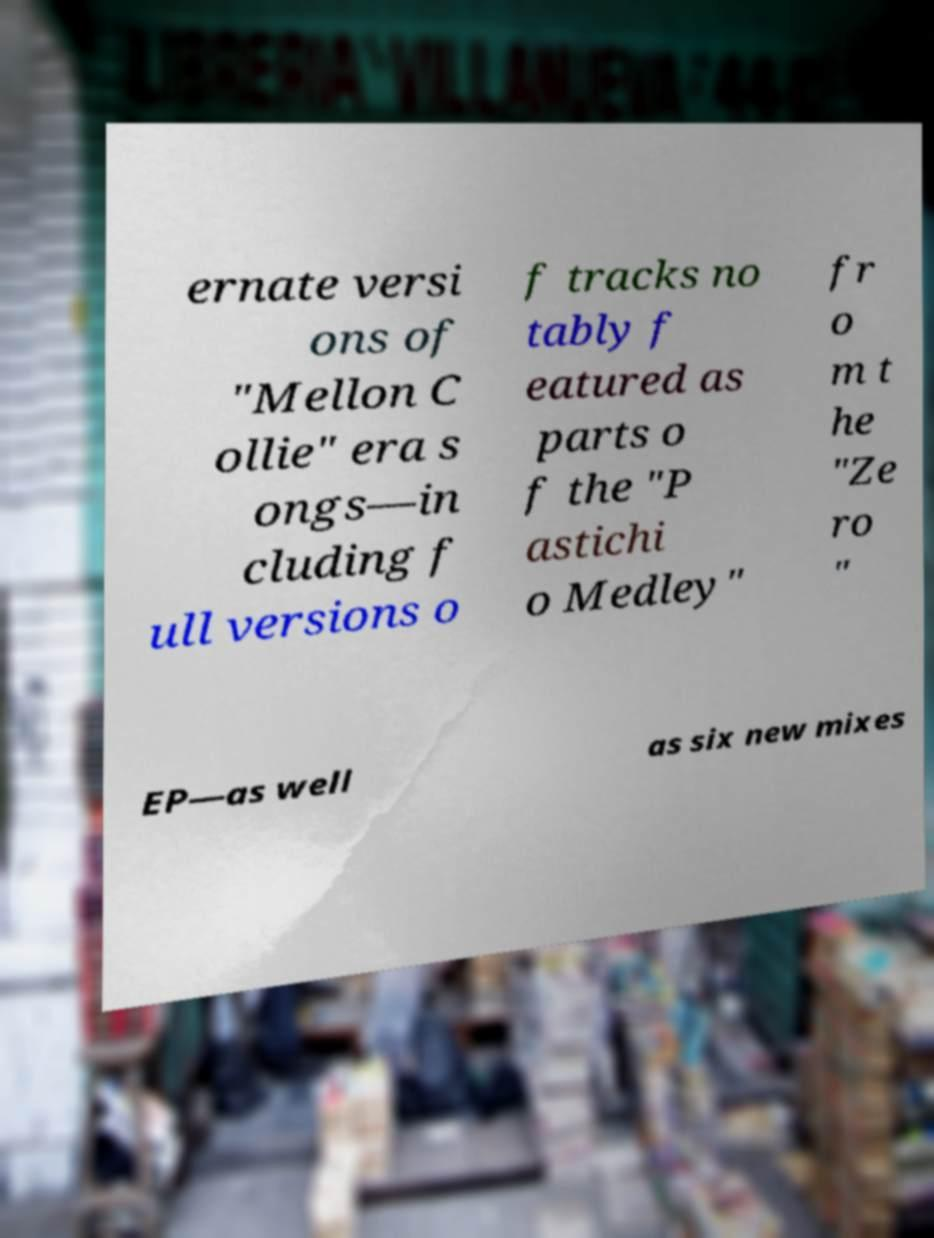Please read and relay the text visible in this image. What does it say? ernate versi ons of "Mellon C ollie" era s ongs—in cluding f ull versions o f tracks no tably f eatured as parts o f the "P astichi o Medley" fr o m t he "Ze ro " EP—as well as six new mixes 